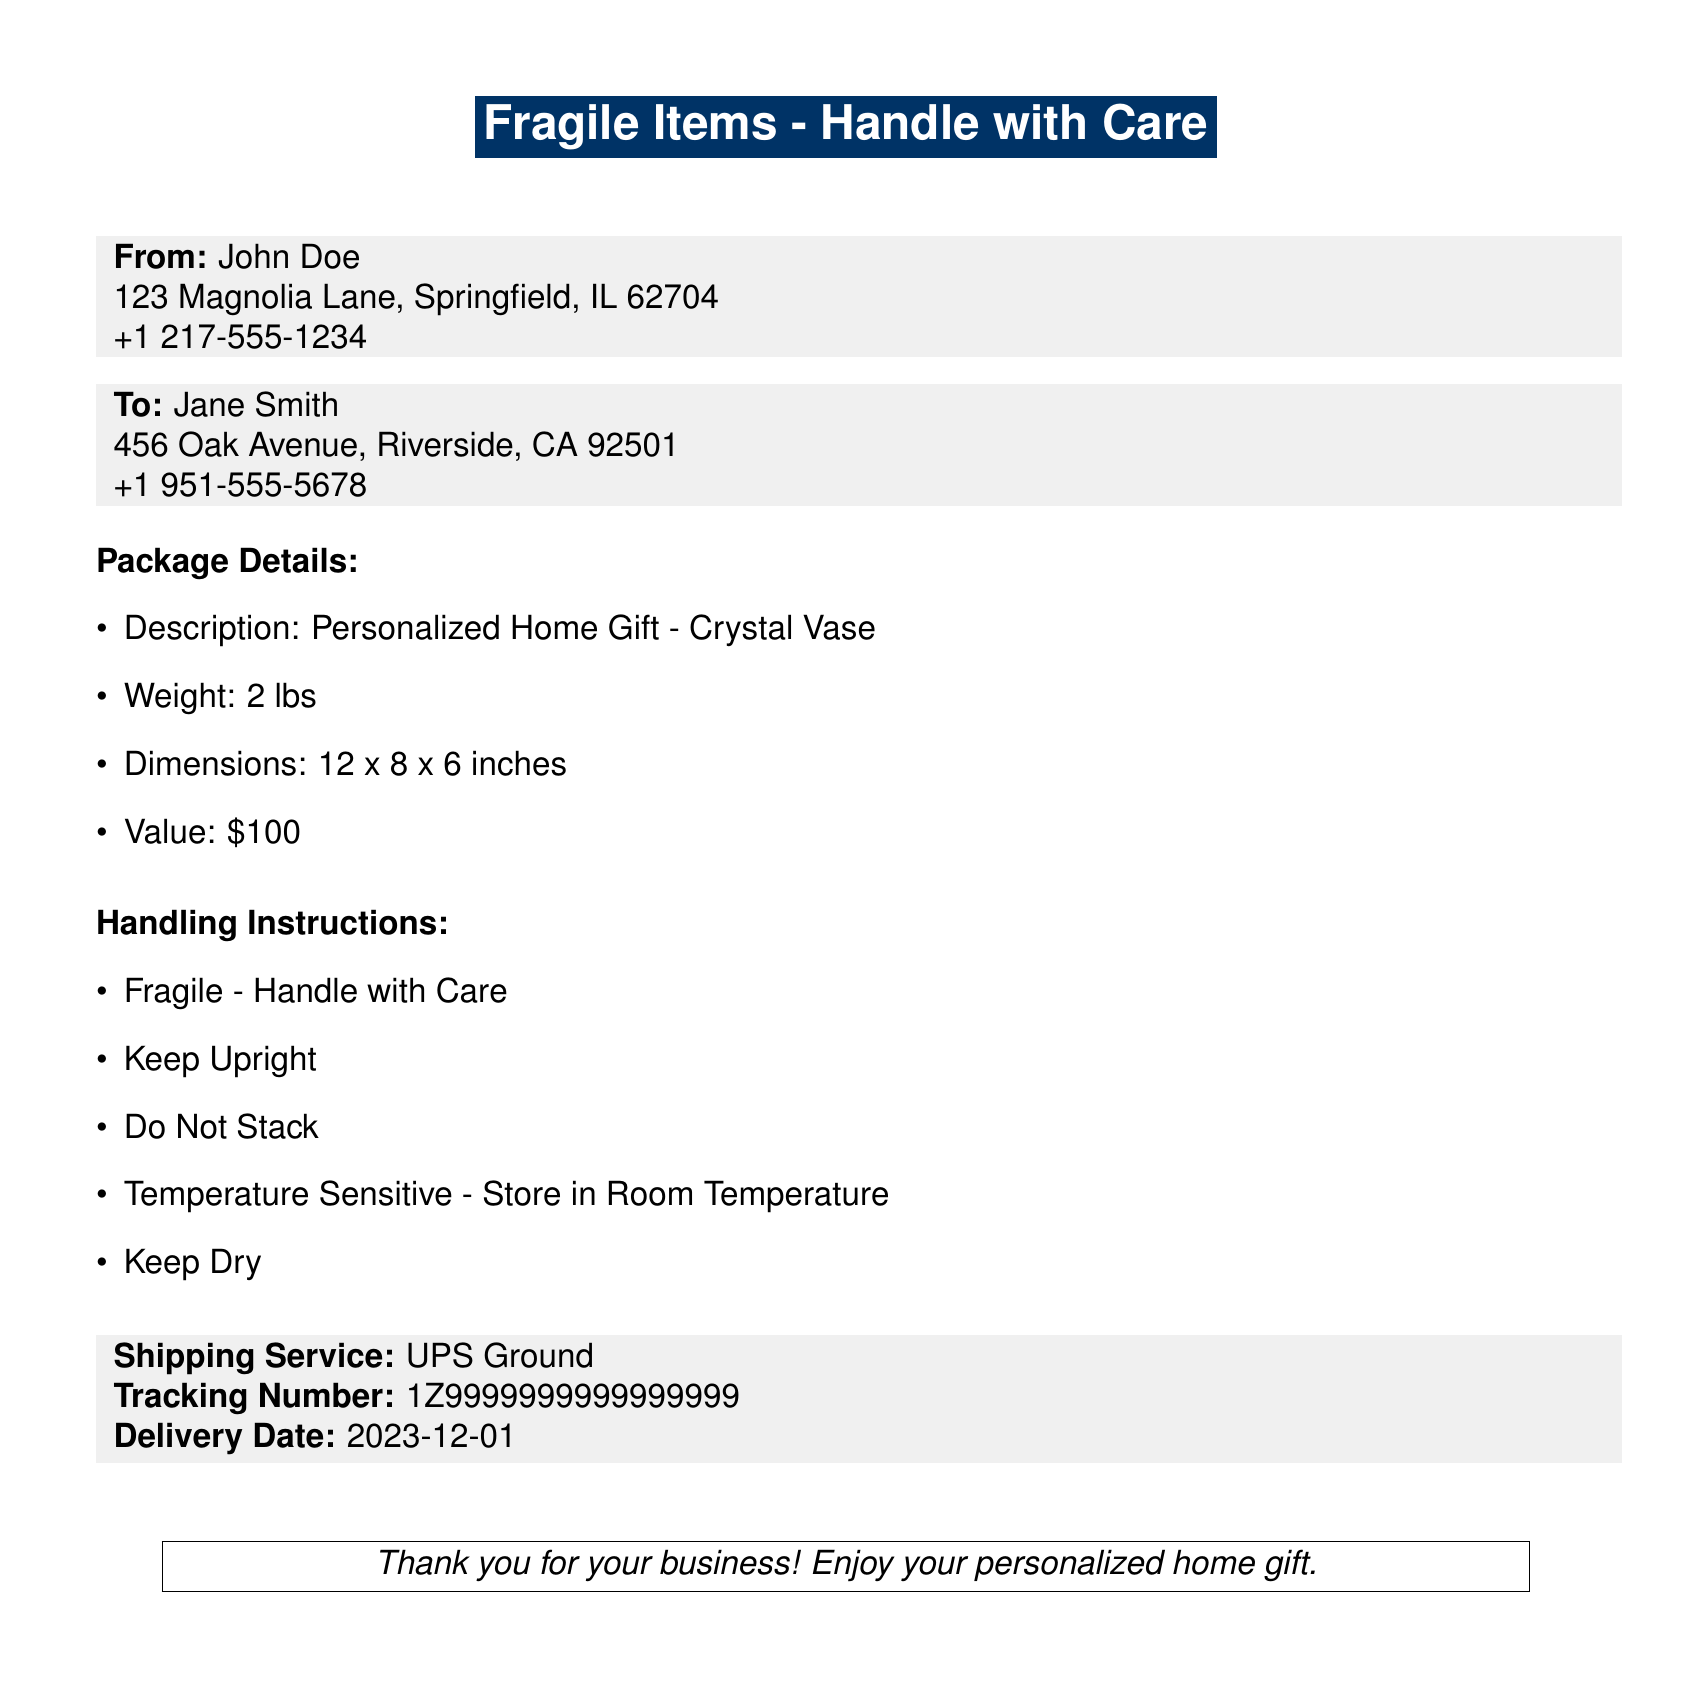What is the description of the item? The document specifies that the item is a personalized home gift, specifically a "Crystal Vase".
Answer: Crystal Vase Who is the sender? The sender's name is clearly mentioned in the document as "John Doe".
Answer: John Doe What is the tracking number? The tracking number is provided in the shipping service section of the document.
Answer: 1Z9999999999999999 What is the weight of the package? The document states that the weight of the package is 2 lbs.
Answer: 2 lbs What are the handling instructions? The handling instructions list specific care to be taken with the item such as being fragile and that it should be kept upright.
Answer: Fragile - Handle with Care, Keep Upright, Do Not Stack, Temperature Sensitive - Store in Room Temperature, Keep Dry When is the delivery date? The document indicates a delivery date of December 1, 2023.
Answer: 2023-12-01 Which shipping service is used? The shipping service utilized, according to the document, is UPS Ground.
Answer: UPS Ground What is the value of the item? The document states the value of the personalized home gift is $100.
Answer: $100 